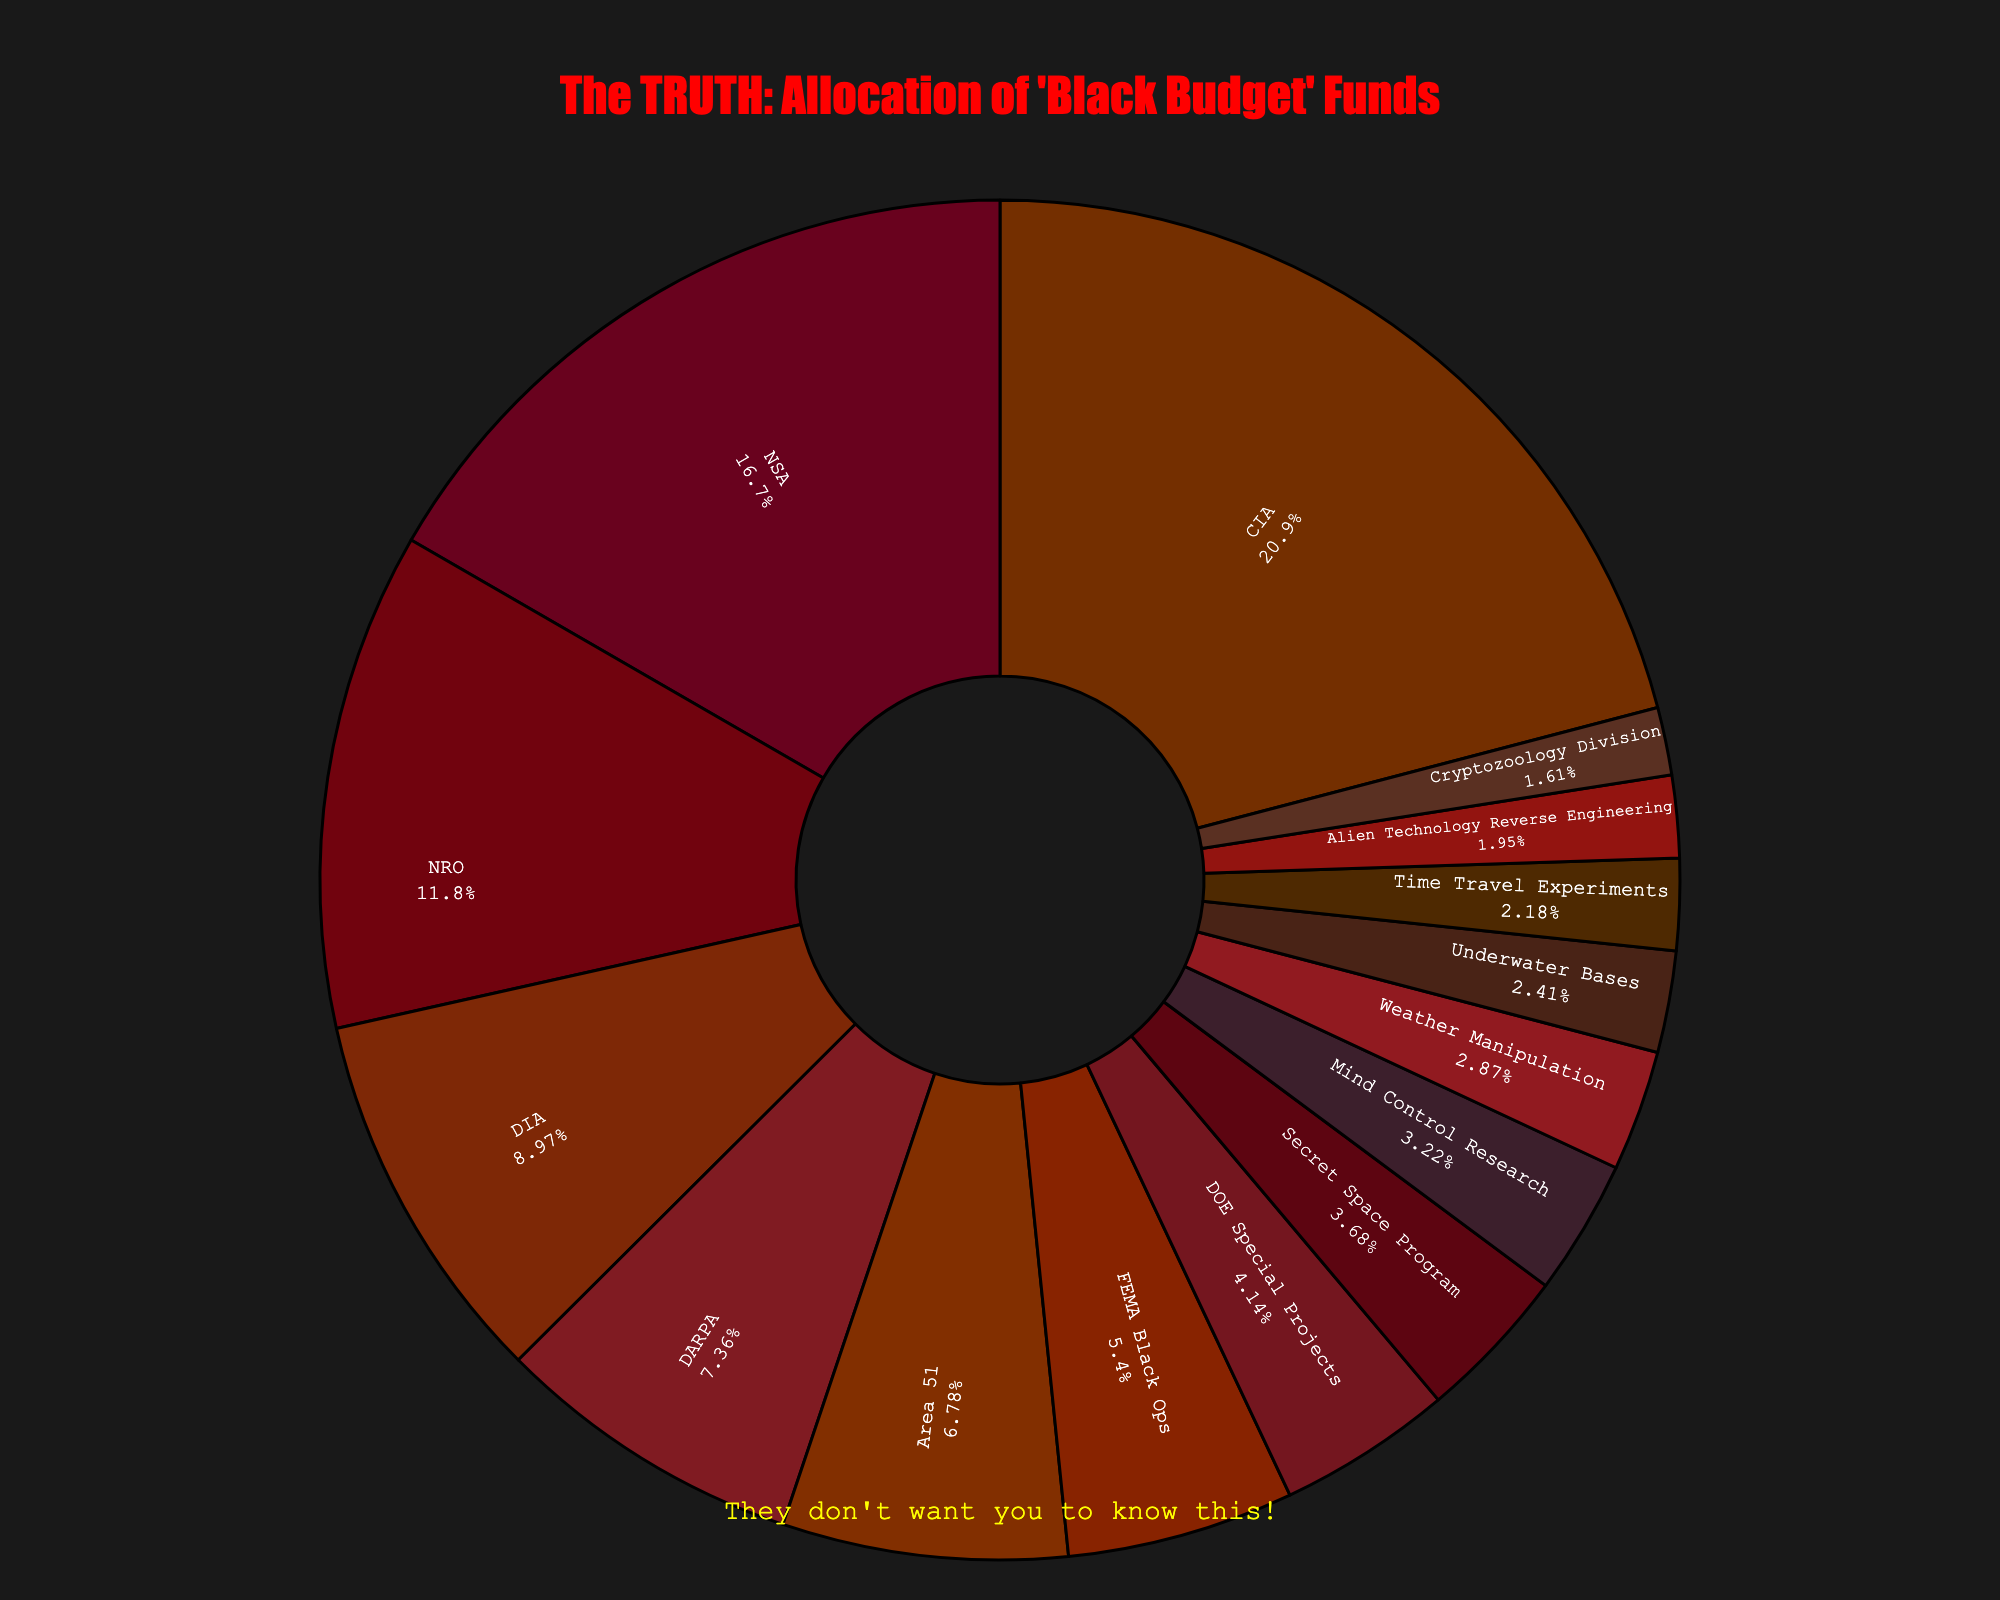Which agency receives the highest allocation of "black budget" funds? The visual representation of the pie chart shows that the CIA slice is the largest.
Answer: CIA What is the combined budget allocation for the CIA and NSA? The CIA's allocation is 18.2 billion USD and the NSA's allocation is 14.5 billion USD. Adding them together, we get 18.2 + 14.5 = 32.7 billion USD.
Answer: 32.7 billion USD Which agency receives more "black budget" funds: Area 51 or FEMA Black Ops? By comparing the slices representing Area 51 and FEMA Black Ops, we see that Area 51's slice is slightly larger than that of FEMA Black Ops.
Answer: Area 51 How much more budget does the NRO receive compared to DARPA? The NRO receives 10.3 billion USD and DARPA receives 6.4 billion USD. Subtracting these values, we get 10.3 - 6.4 = 3.9 billion USD.
Answer: 3.9 billion USD What percentage of the "black budget" funds are allocated to the Secret Space Program? The pie chart shows each sector's percentage, and the Secret Space Program slice is labeled as a portion of the total pie. The label indicates 3.3%.
Answer: 3.3% Are the allocations for DOE Special Projects and FEMA Black Ops closer to each other than to the allocation for CIA? The DOE Special Projects allocation is 3.6 billion USD, and FEMA Black Ops is 4.7 billion USD, with a difference of 4.7 - 3.6 = 1.1 billion USD. The CIA allocation is 18.2 billion USD. Clearly, the allocations for DOE Special Projects and FEMA Black Ops are closer to each other compared to CIA's allocation.
Answer: Yes Which agency has the smallest "black budget" allocation, and what is the amount? The smallest slice in the pie chart corresponds to the Cryptozoology Division, which has an allocation of 1.4 billion USD.
Answer: Cryptozoology Division, 1.4 billion USD What is the average budget allocation for Time Travel Experiments, Alien Technology Reverse Engineering, and Cryptozoology Division? The allocations are 1.9 billion USD (Time Travel Experiments), 1.7 billion USD (Alien Technology Reverse Engineering), and 1.4 billion USD (Cryptozoology Division). Adding these gives us a total of 1.9 + 1.7 + 1.4 = 5 billion USD. Dividing by 3, we get an average of 5 / 3 ≈ 1.67 billion USD.
Answer: 1.67 billion USD Does the budget allocation for Weather Manipulation exceed that for Underwater Bases? The pie chart shows Weather Manipulation at 2.5 billion USD and Underwater Bases at 2.1 billion USD. Since 2.5 is greater than 2.1, Weather Manipulation exceeds Underwater Bases.
Answer: Yes 